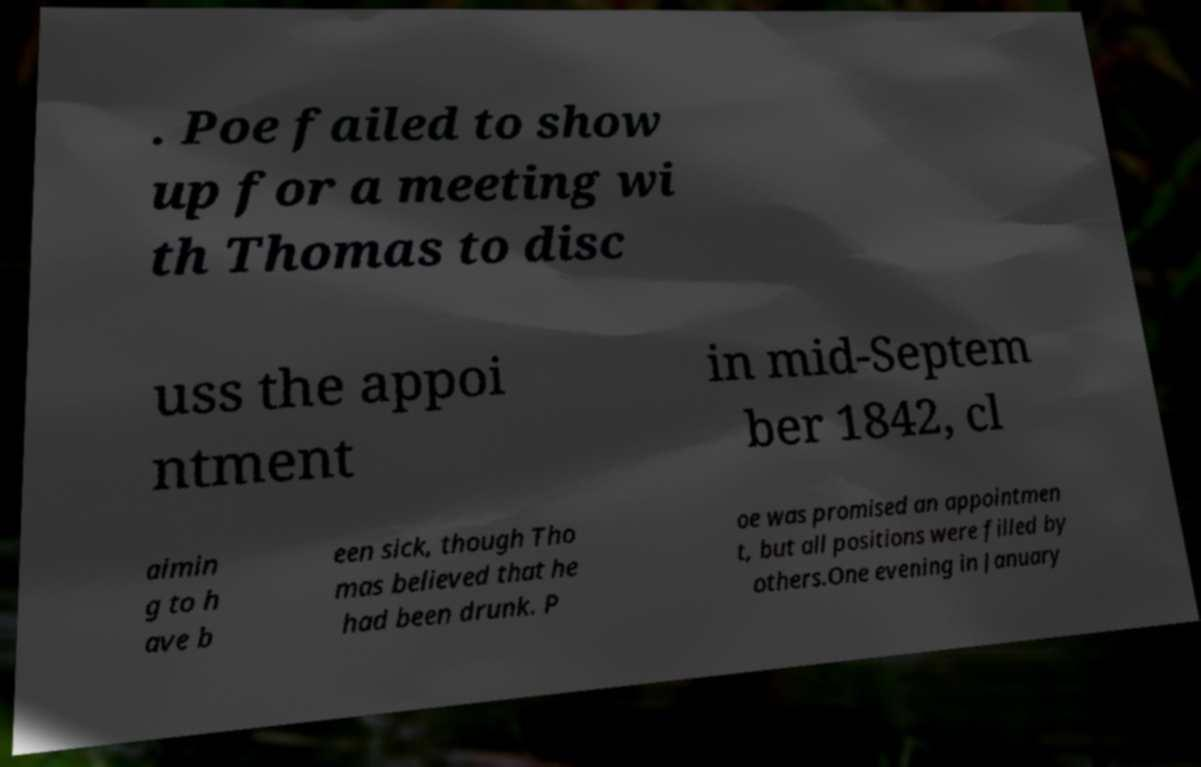For documentation purposes, I need the text within this image transcribed. Could you provide that? . Poe failed to show up for a meeting wi th Thomas to disc uss the appoi ntment in mid-Septem ber 1842, cl aimin g to h ave b een sick, though Tho mas believed that he had been drunk. P oe was promised an appointmen t, but all positions were filled by others.One evening in January 